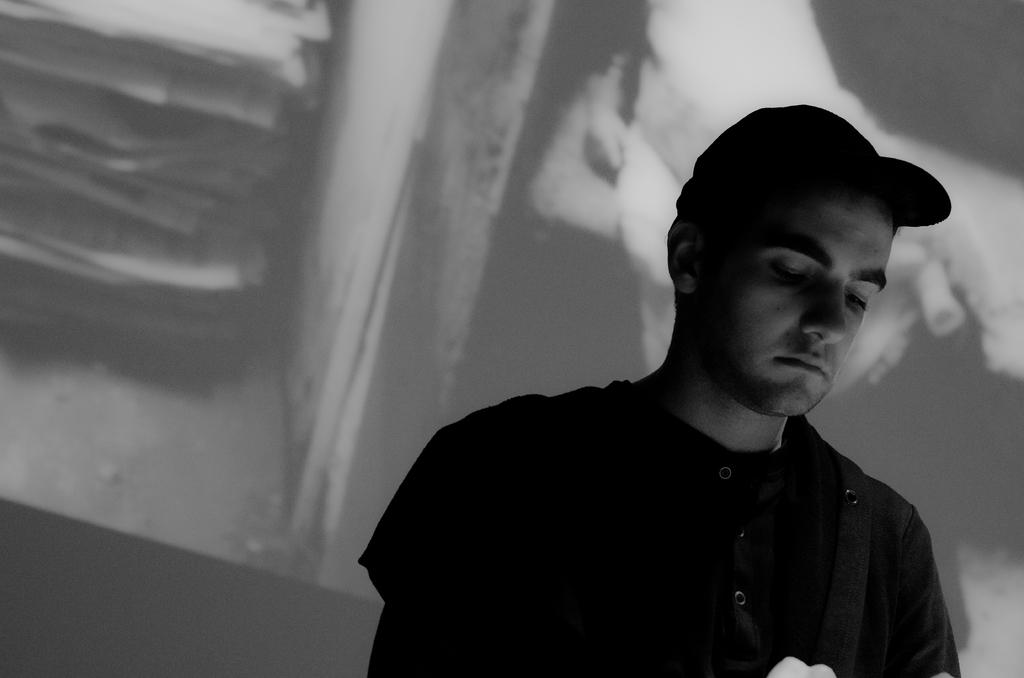What is the person in the image wearing on their head? The person is wearing a cap in the image. Where is the person located in the image? The person is on the right side of the image. What might be visible in the background of the image? There may be a screen in the background of the image. If there is a screen in the background, what can be seen on it? If there are objects visible on the screen, they can be described. How does the person walk through the hole in the image? There is no hole present in the image, so the person cannot walk through it. 